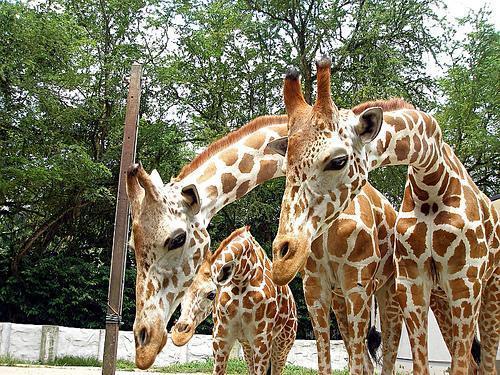How many ears can you see?
Give a very brief answer. 4. How many giraffes are in the photo?
Give a very brief answer. 3. 